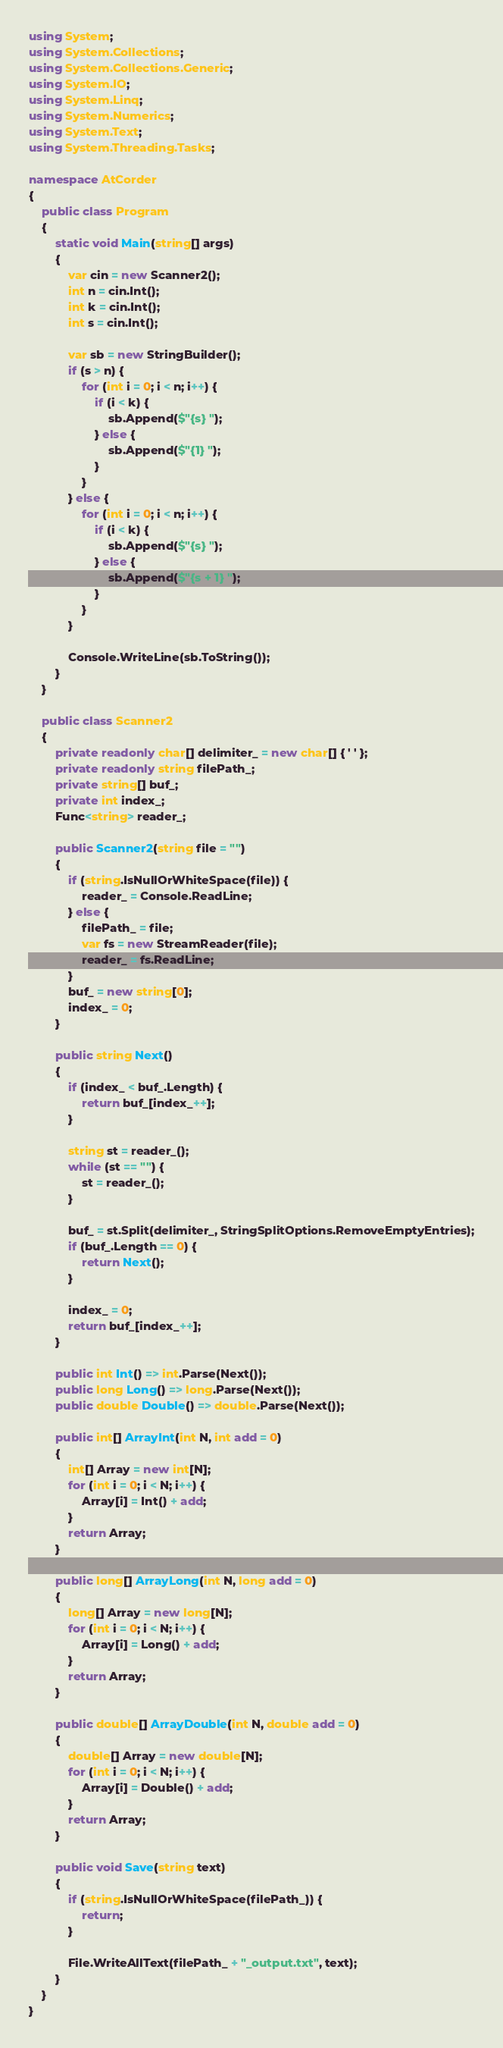Convert code to text. <code><loc_0><loc_0><loc_500><loc_500><_C#_>using System;
using System.Collections;
using System.Collections.Generic;
using System.IO;
using System.Linq;
using System.Numerics;
using System.Text;
using System.Threading.Tasks;

namespace AtCorder
{
	public class Program
	{
		static void Main(string[] args)
		{
			var cin = new Scanner2();
			int n = cin.Int();
			int k = cin.Int();
			int s = cin.Int();

			var sb = new StringBuilder();
			if (s > n) {
				for (int i = 0; i < n; i++) {
					if (i < k) {
						sb.Append($"{s} ");
					} else {
						sb.Append($"{1} ");
					}
				}
			} else {
				for (int i = 0; i < n; i++) {
					if (i < k) {
						sb.Append($"{s} ");
					} else {
						sb.Append($"{s + 1} ");
					}
				}
			}

			Console.WriteLine(sb.ToString());
		}
	}

	public class Scanner2
	{
		private readonly char[] delimiter_ = new char[] { ' ' };
		private readonly string filePath_;
		private string[] buf_;
		private int index_;
		Func<string> reader_;

		public Scanner2(string file = "")
		{
			if (string.IsNullOrWhiteSpace(file)) {
				reader_ = Console.ReadLine;
			} else {
				filePath_ = file;
				var fs = new StreamReader(file);
				reader_ = fs.ReadLine;
			}
			buf_ = new string[0];
			index_ = 0;
		}

		public string Next()
		{
			if (index_ < buf_.Length) {
				return buf_[index_++];
			}

			string st = reader_();
			while (st == "") {
				st = reader_();
			}

			buf_ = st.Split(delimiter_, StringSplitOptions.RemoveEmptyEntries);
			if (buf_.Length == 0) {
				return Next();
			}

			index_ = 0;
			return buf_[index_++];
		}

		public int Int() => int.Parse(Next());
		public long Long() => long.Parse(Next());
		public double Double() => double.Parse(Next());

		public int[] ArrayInt(int N, int add = 0)
		{
			int[] Array = new int[N];
			for (int i = 0; i < N; i++) {
				Array[i] = Int() + add;
			}
			return Array;
		}

		public long[] ArrayLong(int N, long add = 0)
		{
			long[] Array = new long[N];
			for (int i = 0; i < N; i++) {
				Array[i] = Long() + add;
			}
			return Array;
		}

		public double[] ArrayDouble(int N, double add = 0)
		{
			double[] Array = new double[N];
			for (int i = 0; i < N; i++) {
				Array[i] = Double() + add;
			}
			return Array;
		}

		public void Save(string text)
		{
			if (string.IsNullOrWhiteSpace(filePath_)) {
				return;
			}

			File.WriteAllText(filePath_ + "_output.txt", text);
		}
	}
}</code> 